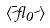Convert formula to latex. <formula><loc_0><loc_0><loc_500><loc_500>\langle \overline { \psi } \gamma _ { 0 } \psi \rangle</formula> 